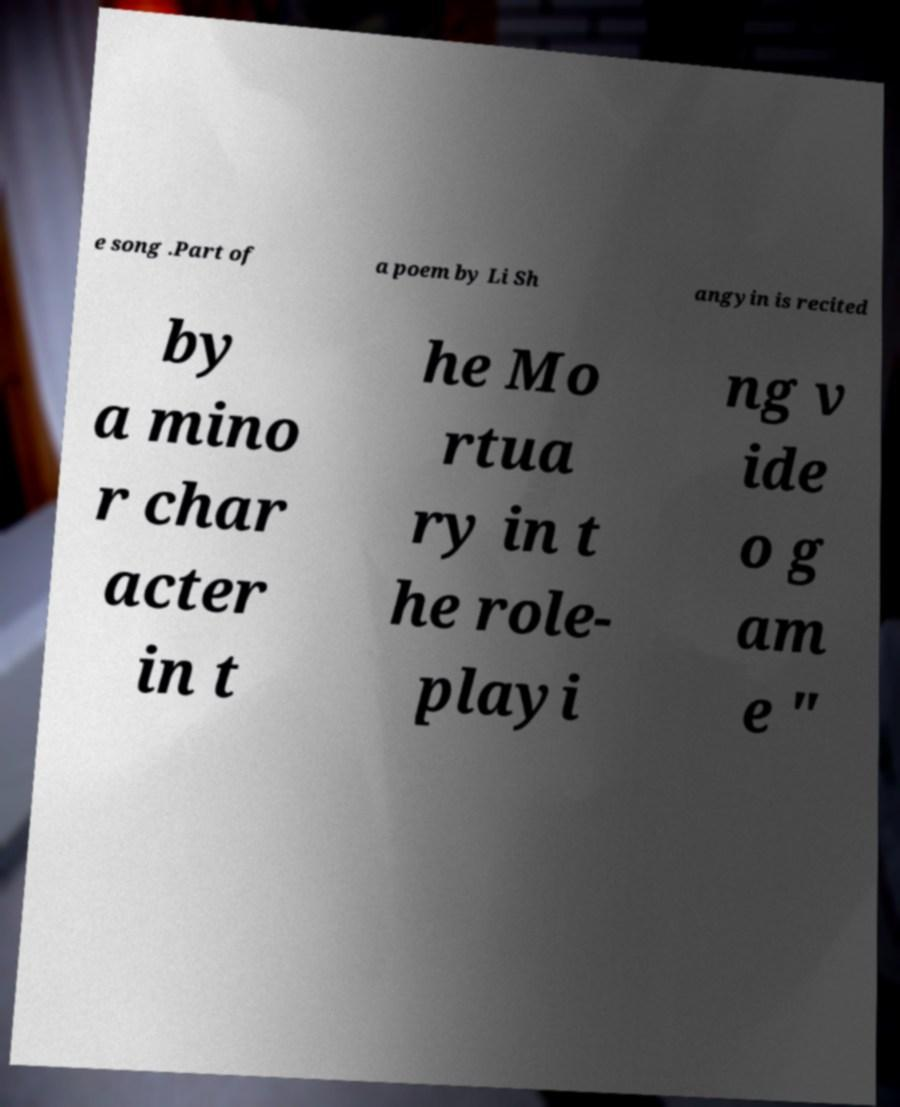For documentation purposes, I need the text within this image transcribed. Could you provide that? e song .Part of a poem by Li Sh angyin is recited by a mino r char acter in t he Mo rtua ry in t he role- playi ng v ide o g am e " 